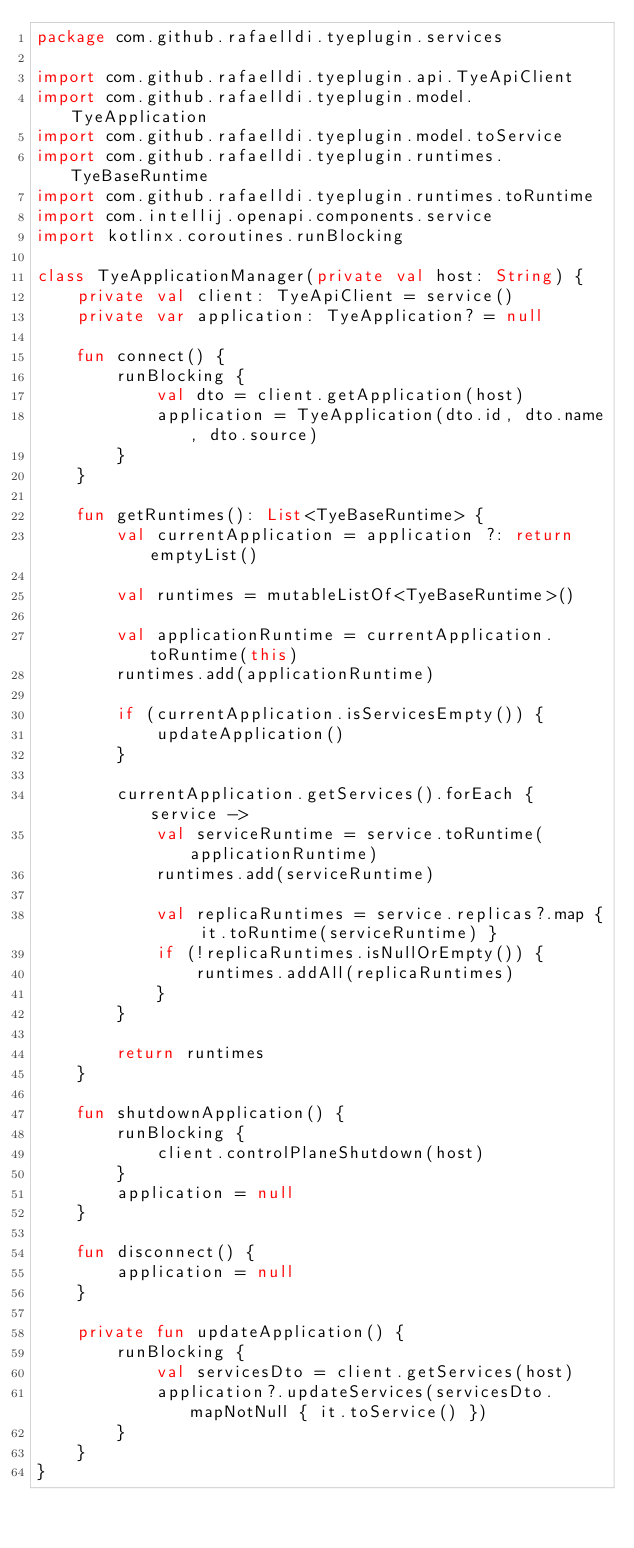<code> <loc_0><loc_0><loc_500><loc_500><_Kotlin_>package com.github.rafaelldi.tyeplugin.services

import com.github.rafaelldi.tyeplugin.api.TyeApiClient
import com.github.rafaelldi.tyeplugin.model.TyeApplication
import com.github.rafaelldi.tyeplugin.model.toService
import com.github.rafaelldi.tyeplugin.runtimes.TyeBaseRuntime
import com.github.rafaelldi.tyeplugin.runtimes.toRuntime
import com.intellij.openapi.components.service
import kotlinx.coroutines.runBlocking

class TyeApplicationManager(private val host: String) {
    private val client: TyeApiClient = service()
    private var application: TyeApplication? = null

    fun connect() {
        runBlocking {
            val dto = client.getApplication(host)
            application = TyeApplication(dto.id, dto.name, dto.source)
        }
    }

    fun getRuntimes(): List<TyeBaseRuntime> {
        val currentApplication = application ?: return emptyList()

        val runtimes = mutableListOf<TyeBaseRuntime>()

        val applicationRuntime = currentApplication.toRuntime(this)
        runtimes.add(applicationRuntime)

        if (currentApplication.isServicesEmpty()) {
            updateApplication()
        }

        currentApplication.getServices().forEach { service ->
            val serviceRuntime = service.toRuntime(applicationRuntime)
            runtimes.add(serviceRuntime)

            val replicaRuntimes = service.replicas?.map { it.toRuntime(serviceRuntime) }
            if (!replicaRuntimes.isNullOrEmpty()) {
                runtimes.addAll(replicaRuntimes)
            }
        }

        return runtimes
    }

    fun shutdownApplication() {
        runBlocking {
            client.controlPlaneShutdown(host)
        }
        application = null
    }

    fun disconnect() {
        application = null
    }

    private fun updateApplication() {
        runBlocking {
            val servicesDto = client.getServices(host)
            application?.updateServices(servicesDto.mapNotNull { it.toService() })
        }
    }
}
</code> 